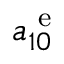Convert formula to latex. <formula><loc_0><loc_0><loc_500><loc_500>a _ { 1 0 } ^ { e }</formula> 